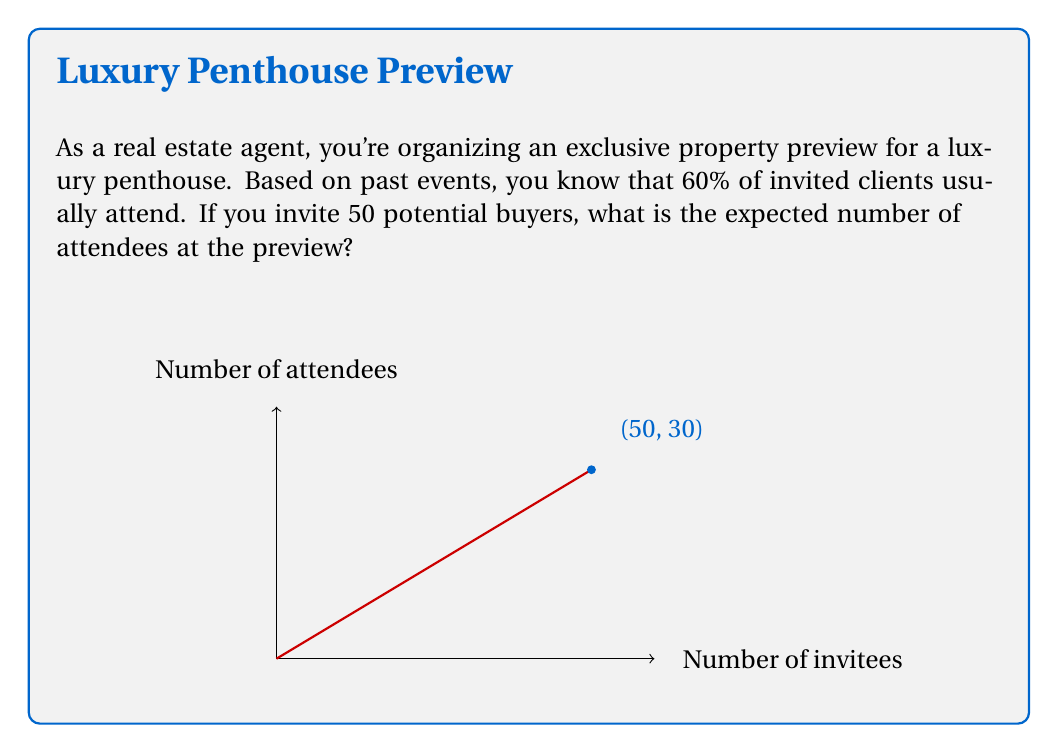Can you solve this math problem? To solve this problem, we'll use the concept of expected value in probability theory.

1) Let X be the random variable representing the number of attendees.

2) Each invited client has a 60% (or 0.6) probability of attending.

3) The number of invitees is 50.

4) This scenario follows a binomial distribution with parameters n = 50 and p = 0.6.

5) For a binomial distribution, the expected value is given by:

   $$ E(X) = np $$

   Where:
   n = number of trials (invitees)
   p = probability of success (attendance)

6) Substituting our values:

   $$ E(X) = 50 \times 0.6 = 30 $$

Therefore, the expected number of attendees is 30.
Answer: 30 attendees 